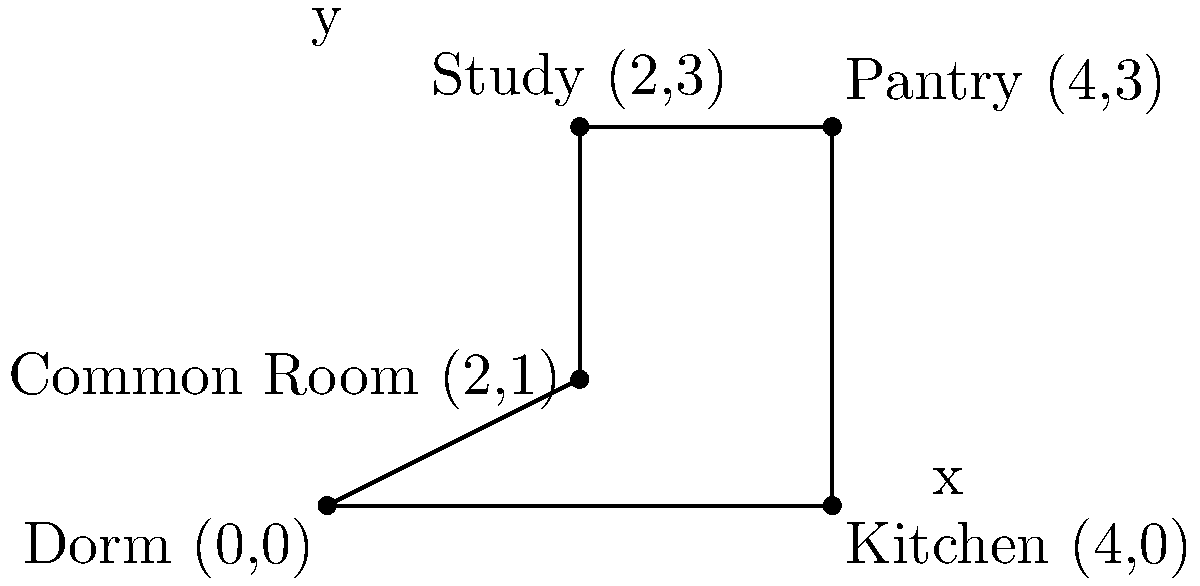Malory Towers' Darrell Rivers is planning a midnight feast with her friends. The school layout is represented on a coordinate system where each unit represents 10 meters. Darrell starts at the Dorm (0,0) and needs to visit the Kitchen (4,0), then the Pantry (4,3), followed by the Study (2,3), and finally the Common Room (2,1) before returning to the Dorm. What is the total distance Darrell will travel in meters? Let's break this down step-by-step:

1) Dorm (0,0) to Kitchen (4,0):
   Distance = $\sqrt{(4-0)^2 + (0-0)^2} = 4$ units

2) Kitchen (4,0) to Pantry (4,3):
   Distance = $\sqrt{(4-4)^2 + (3-0)^2} = 3$ units

3) Pantry (4,3) to Study (2,3):
   Distance = $\sqrt{(2-4)^2 + (3-3)^2} = 2$ units

4) Study (2,3) to Common Room (2,1):
   Distance = $\sqrt{(2-2)^2 + (1-3)^2} = 2$ units

5) Common Room (2,1) back to Dorm (0,0):
   Distance = $\sqrt{(0-2)^2 + (0-1)^2} = \sqrt{5}$ units

Total distance = $4 + 3 + 2 + 2 + \sqrt{5}$ units
               = $11 + \sqrt{5}$ units

Each unit represents 10 meters, so:
Total distance in meters = $(11 + \sqrt{5}) \times 10$
                         = $110 + 10\sqrt{5}$ meters
Answer: $110 + 10\sqrt{5}$ meters 